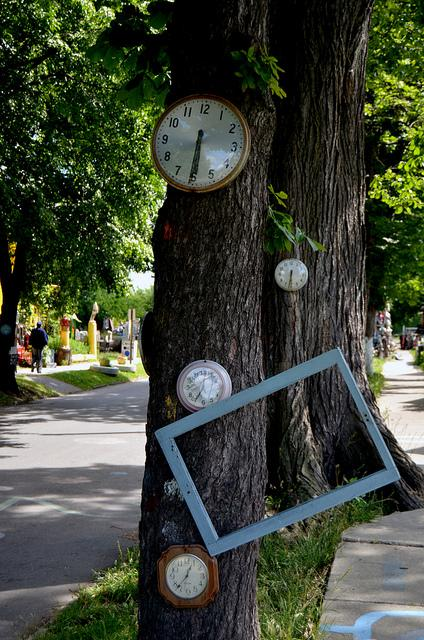What time can be seen on the highest clock? six thirty 